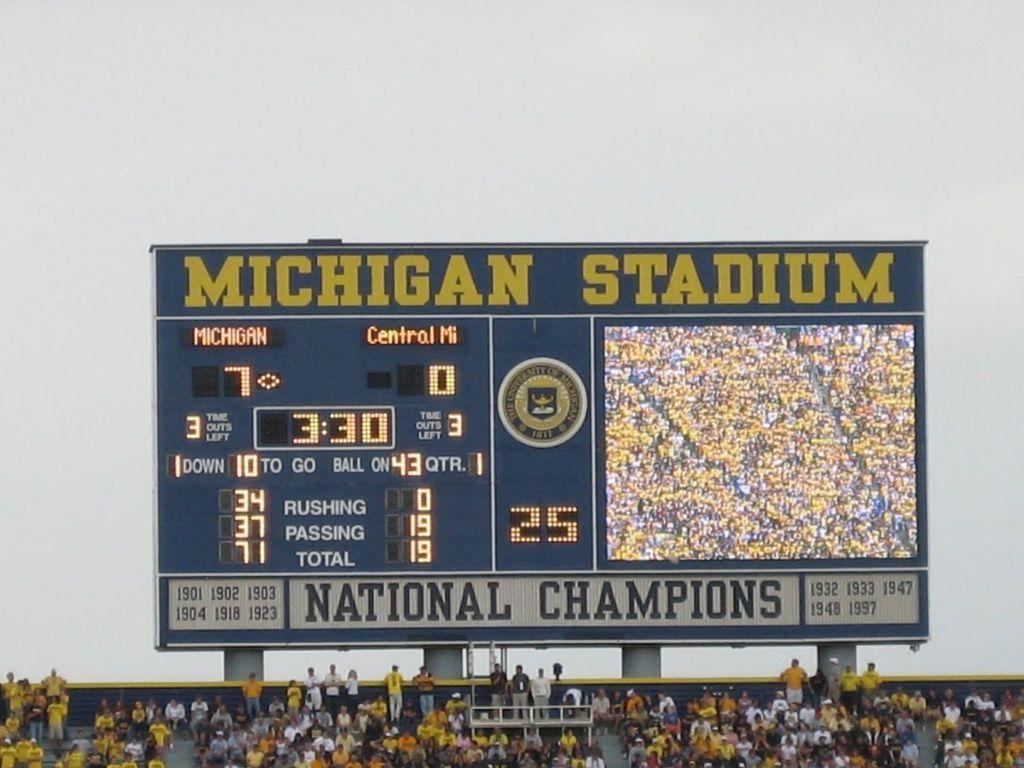<image>
Present a compact description of the photo's key features. A Michigan Stadium billboard is a scoreboard located at the top of the bleachers at a game with a crowd of people watching. 